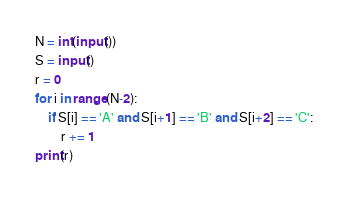<code> <loc_0><loc_0><loc_500><loc_500><_Python_>N = int(input())
S = input()
r = 0
for i in range(N-2):
    if S[i] == 'A' and S[i+1] == 'B' and S[i+2] == 'C':
        r += 1
print(r)
</code> 